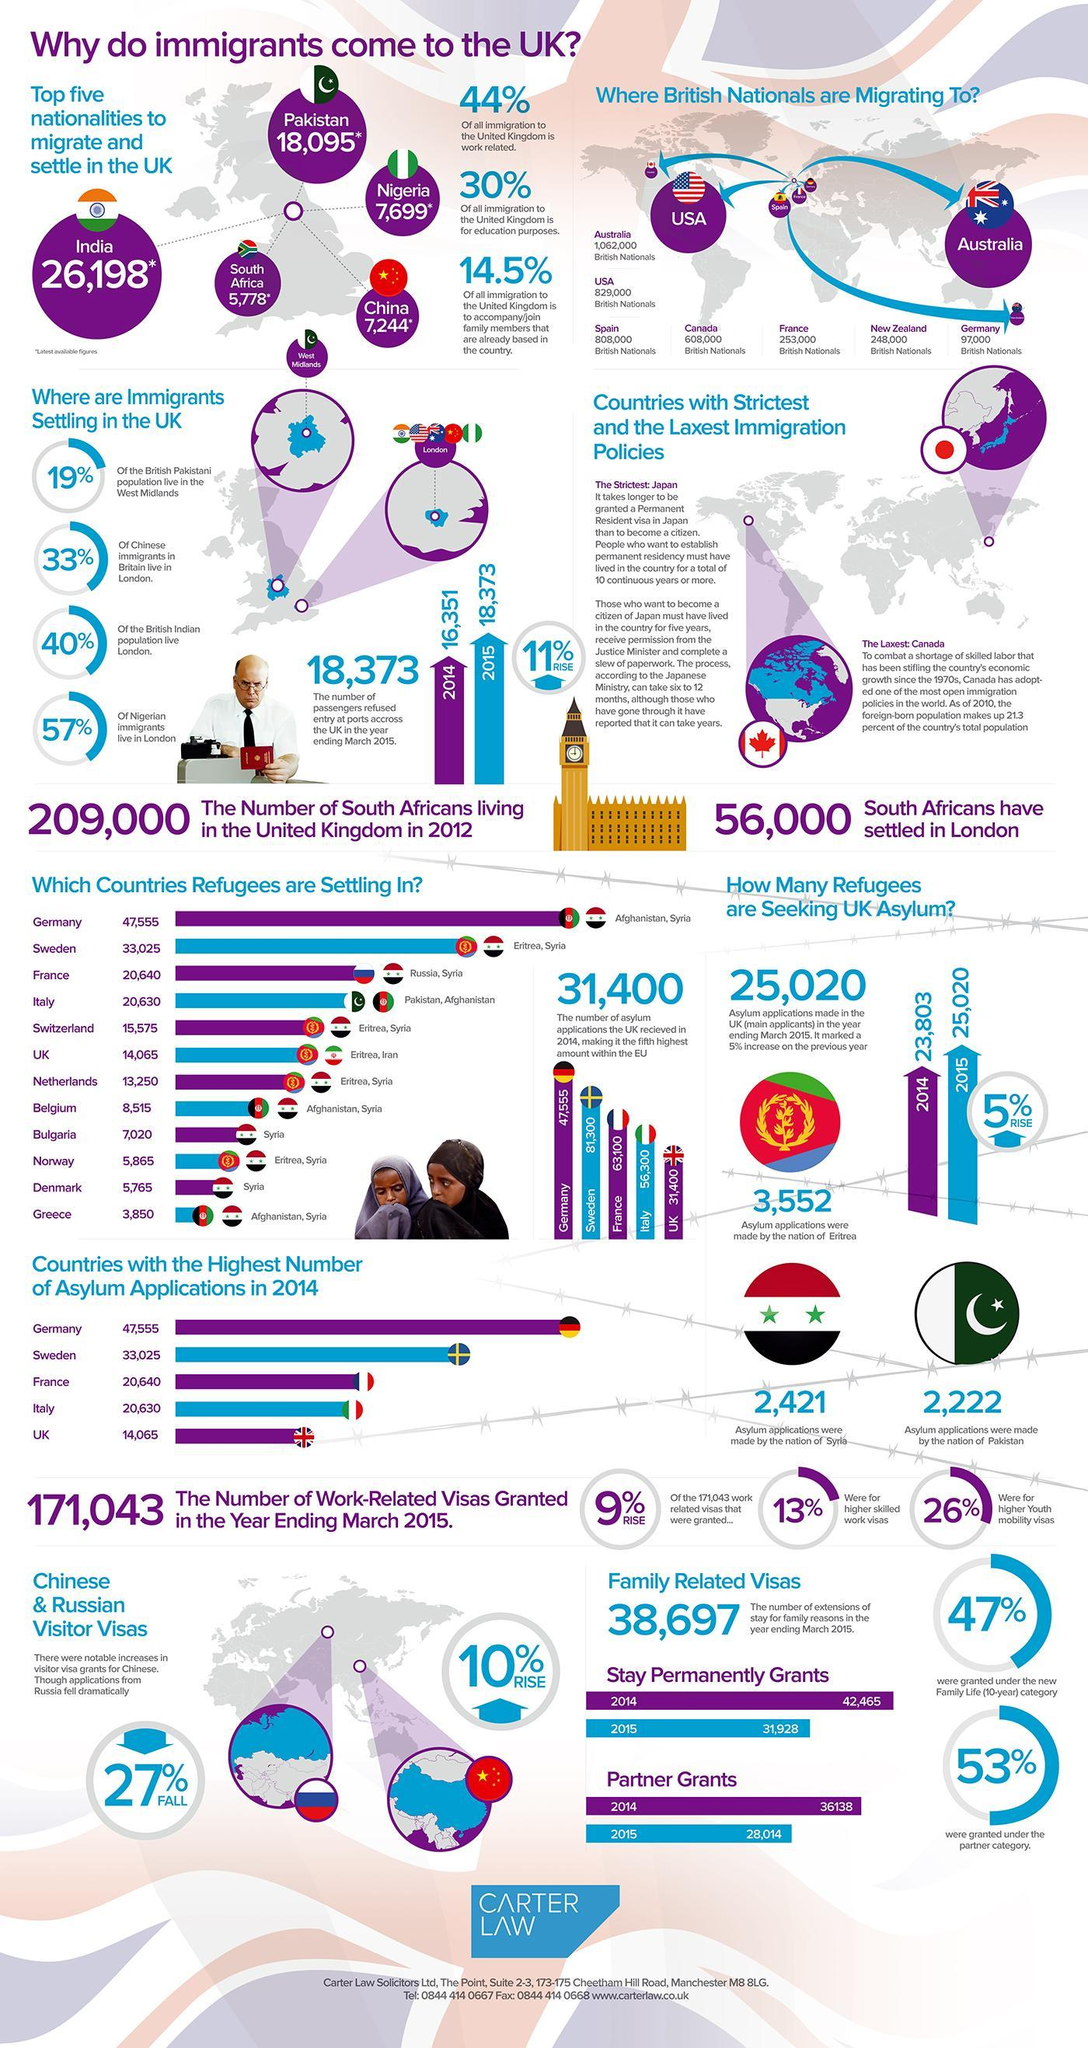the percentage of fall in visiting visas grants for Russia is?
Answer the question with a short phrase. 27% More people from the UK migrate to France or Canada? Canada Which country has got more asylum in 2014 - France or Italy? France Which country have made more asylum in 2014 - Syria or Pakistan? Syria What is the top reason people migrate to UK from other countries? work related To which country British nationals migrate to the most? Australia Which countries' refugees are settling in Netherlands? Eritrea, Syria visiting visas grants of which country has increased? China Which country have more nationalities migrated to UK - China or Nigeria? Nigeria How many passengers were denied entry to the UK in 2014? 16351 How many people did migrate from China to UK according to the latest update? 7244 citizens of which country migrate to UK the most? India 